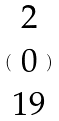Convert formula to latex. <formula><loc_0><loc_0><loc_500><loc_500>( \begin{matrix} 2 \\ 0 \\ 1 9 \end{matrix} )</formula> 